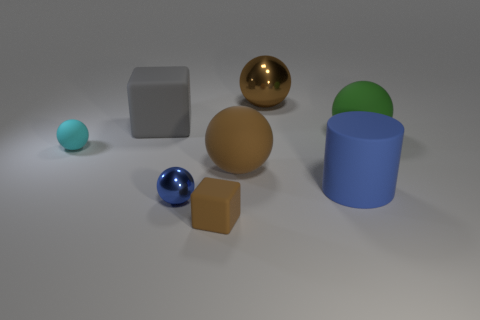Subtract all green spheres. How many spheres are left? 4 Subtract all big metal spheres. How many spheres are left? 4 Subtract all yellow spheres. Subtract all red cylinders. How many spheres are left? 5 Add 1 metal objects. How many objects exist? 9 Subtract 0 gray spheres. How many objects are left? 8 Subtract all cylinders. How many objects are left? 7 Subtract all tiny gray blocks. Subtract all large brown objects. How many objects are left? 6 Add 5 big blue things. How many big blue things are left? 6 Add 7 large blue things. How many large blue things exist? 8 